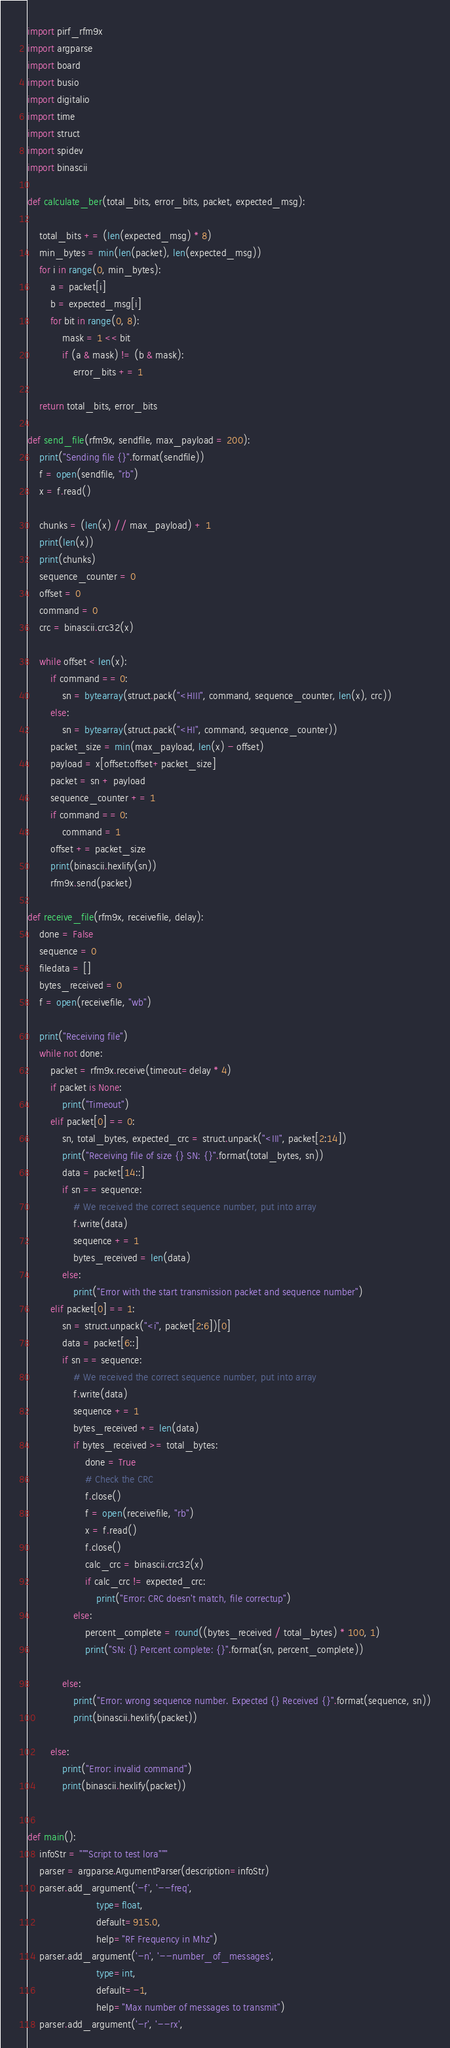<code> <loc_0><loc_0><loc_500><loc_500><_Python_>import pirf_rfm9x
import argparse
import board
import busio
import digitalio
import time
import struct
import spidev
import binascii

def calculate_ber(total_bits, error_bits, packet, expected_msg):

    total_bits += (len(expected_msg) * 8)
    min_bytes = min(len(packet), len(expected_msg))
    for i in range(0, min_bytes):
        a = packet[i]
        b = expected_msg[i]
        for bit in range(0, 8):
            mask = 1 << bit
            if (a & mask) != (b & mask):
                error_bits += 1

    return total_bits, error_bits

def send_file(rfm9x, sendfile, max_payload = 200):
    print("Sending file {}".format(sendfile))
    f = open(sendfile, "rb")
    x = f.read()

    chunks = (len(x) // max_payload) + 1
    print(len(x))
    print(chunks)
    sequence_counter = 0
    offset = 0
    command = 0
    crc = binascii.crc32(x)

    while offset < len(x):
        if command == 0:
            sn = bytearray(struct.pack("<HIII", command, sequence_counter, len(x), crc))
        else:
            sn = bytearray(struct.pack("<HI", command, sequence_counter))
        packet_size = min(max_payload, len(x) - offset)
        payload = x[offset:offset+packet_size]
        packet = sn + payload
        sequence_counter += 1
        if command == 0:
            command = 1
        offset += packet_size
        print(binascii.hexlify(sn))
        rfm9x.send(packet)

def receive_file(rfm9x, receivefile, delay):
    done = False
    sequence = 0
    filedata = []
    bytes_received = 0
    f = open(receivefile, "wb")

    print("Receiving file")
    while not done:
        packet = rfm9x.receive(timeout=delay * 4)
        if packet is None:
            print("Timeout")
        elif packet[0] == 0:
            sn, total_bytes, expected_crc = struct.unpack("<III", packet[2:14])
            print("Receiving file of size {} SN: {}".format(total_bytes, sn))
            data = packet[14::]
            if sn == sequence:
                # We received the correct sequence number, put into array
                f.write(data)
                sequence += 1
                bytes_received = len(data)
            else:
                print("Error with the start transmission packet and sequence number")
        elif packet[0] == 1:
            sn = struct.unpack("<i", packet[2:6])[0]
            data = packet[6::]
            if sn == sequence:
                # We received the correct sequence number, put into array
                f.write(data)
                sequence += 1
                bytes_received += len(data)
                if bytes_received >= total_bytes:
                    done = True
                    # Check the CRC
                    f.close()
                    f = open(receivefile, "rb")
                    x = f.read()
                    f.close()
                    calc_crc = binascii.crc32(x)
                    if calc_crc != expected_crc:
                        print("Error: CRC doesn't match, file correctup")
                else:
                    percent_complete = round((bytes_received / total_bytes) * 100, 1)
                    print("SN: {} Percent complete: {}".format(sn, percent_complete))

            else:
                print("Error: wrong sequence number. Expected {} Received {}".format(sequence, sn))
                print(binascii.hexlify(packet))

        else:
            print("Error: invalid command")
            print(binascii.hexlify(packet))


def main():
    infoStr = """Script to test lora"""
    parser = argparse.ArgumentParser(description=infoStr)
    parser.add_argument('-f', '--freq',
                        type=float,
                        default=915.0,
                        help="RF Frequency in Mhz")
    parser.add_argument('-n', '--number_of_messages',
                        type=int,
                        default=-1,
                        help="Max number of messages to transmit")
    parser.add_argument('-r', '--rx',</code> 